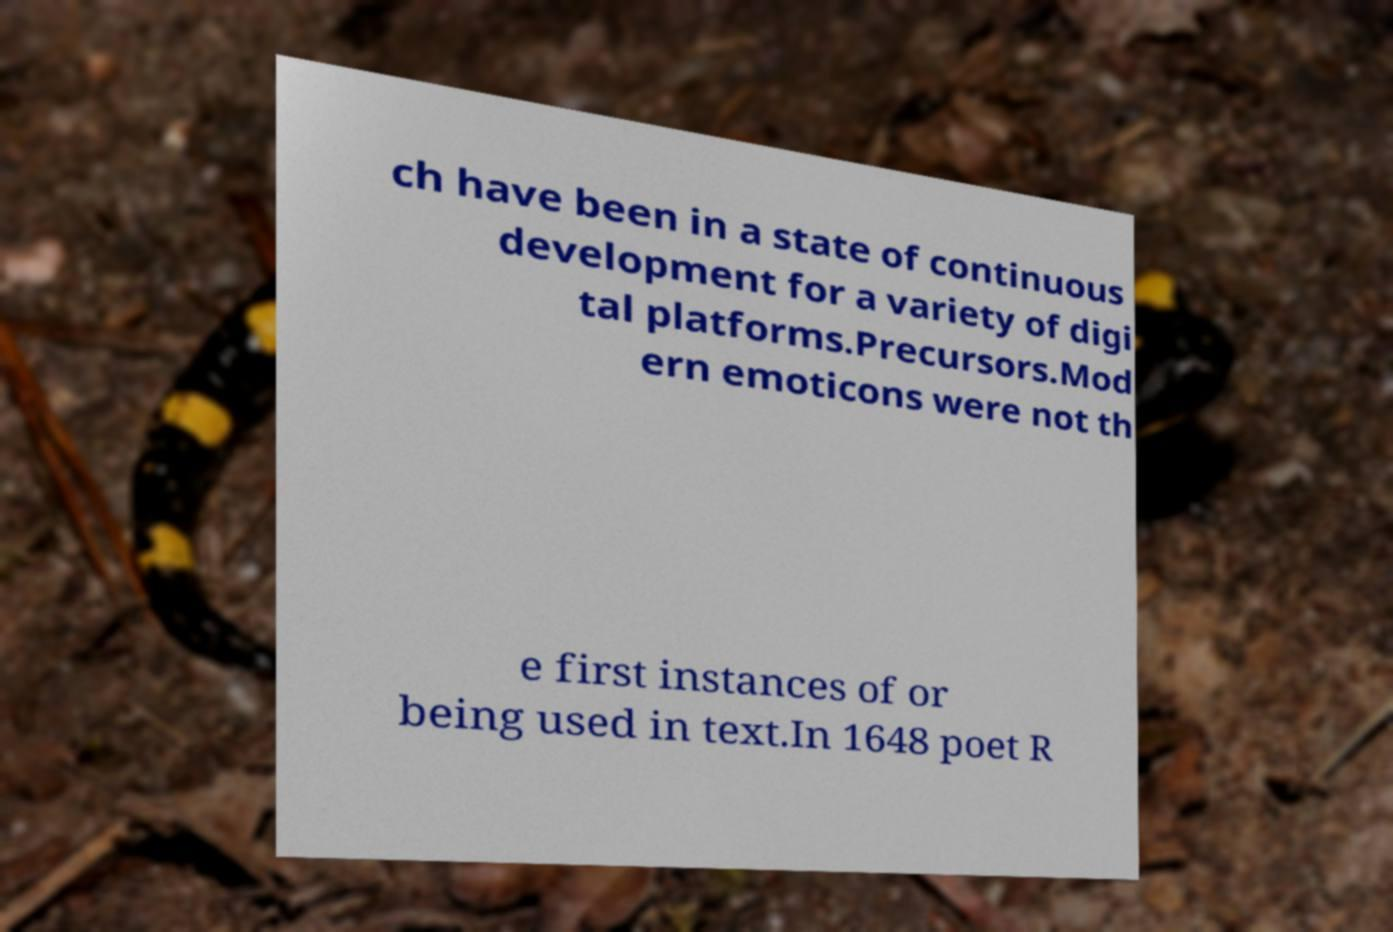There's text embedded in this image that I need extracted. Can you transcribe it verbatim? ch have been in a state of continuous development for a variety of digi tal platforms.Precursors.Mod ern emoticons were not th e first instances of or being used in text.In 1648 poet R 